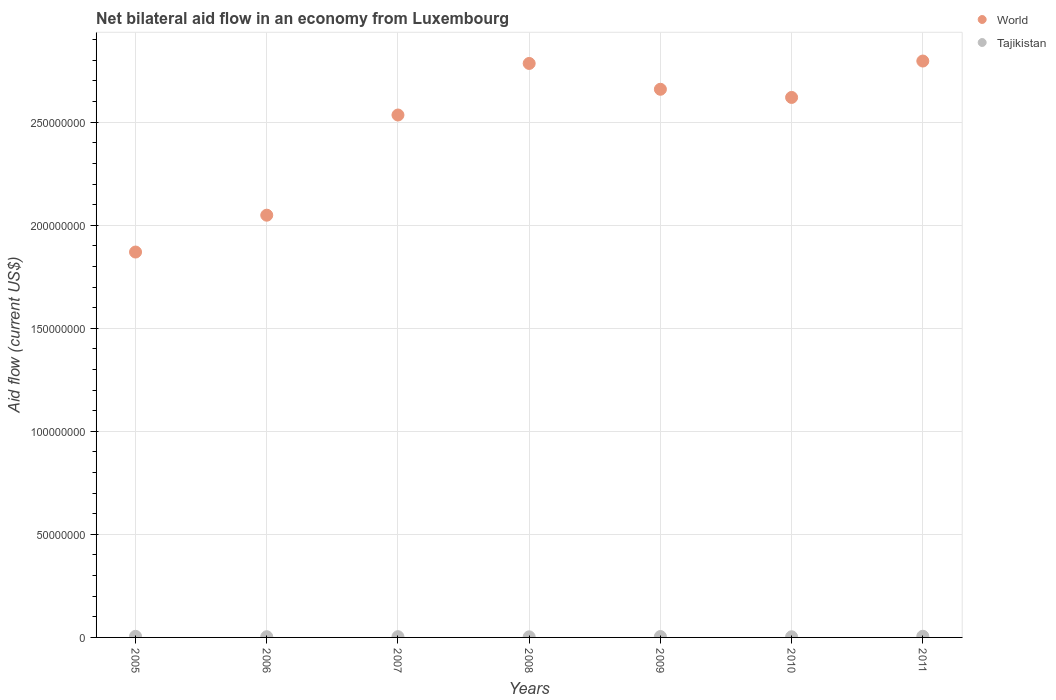How many different coloured dotlines are there?
Your answer should be compact. 2. Across all years, what is the maximum net bilateral aid flow in Tajikistan?
Offer a very short reply. 5.70e+05. Across all years, what is the minimum net bilateral aid flow in World?
Provide a succinct answer. 1.87e+08. In which year was the net bilateral aid flow in Tajikistan minimum?
Give a very brief answer. 2008. What is the total net bilateral aid flow in World in the graph?
Your response must be concise. 1.73e+09. What is the difference between the net bilateral aid flow in Tajikistan in 2006 and the net bilateral aid flow in World in 2011?
Provide a short and direct response. -2.79e+08. What is the average net bilateral aid flow in World per year?
Provide a short and direct response. 2.47e+08. In the year 2005, what is the difference between the net bilateral aid flow in World and net bilateral aid flow in Tajikistan?
Make the answer very short. 1.86e+08. What is the ratio of the net bilateral aid flow in Tajikistan in 2006 to that in 2011?
Offer a very short reply. 0.6. Is the difference between the net bilateral aid flow in World in 2005 and 2010 greater than the difference between the net bilateral aid flow in Tajikistan in 2005 and 2010?
Your response must be concise. No. What is the difference between the highest and the second highest net bilateral aid flow in World?
Offer a very short reply. 1.17e+06. In how many years, is the net bilateral aid flow in Tajikistan greater than the average net bilateral aid flow in Tajikistan taken over all years?
Keep it short and to the point. 3. Is the sum of the net bilateral aid flow in Tajikistan in 2008 and 2010 greater than the maximum net bilateral aid flow in World across all years?
Your response must be concise. No. Does the net bilateral aid flow in World monotonically increase over the years?
Keep it short and to the point. No. Is the net bilateral aid flow in World strictly greater than the net bilateral aid flow in Tajikistan over the years?
Your answer should be very brief. Yes. Is the net bilateral aid flow in Tajikistan strictly less than the net bilateral aid flow in World over the years?
Provide a short and direct response. Yes. How many dotlines are there?
Offer a terse response. 2. How many years are there in the graph?
Offer a terse response. 7. Are the values on the major ticks of Y-axis written in scientific E-notation?
Your response must be concise. No. Does the graph contain any zero values?
Offer a terse response. No. Where does the legend appear in the graph?
Ensure brevity in your answer.  Top right. How many legend labels are there?
Make the answer very short. 2. How are the legend labels stacked?
Offer a very short reply. Vertical. What is the title of the graph?
Your answer should be compact. Net bilateral aid flow in an economy from Luxembourg. What is the label or title of the X-axis?
Offer a terse response. Years. What is the label or title of the Y-axis?
Provide a succinct answer. Aid flow (current US$). What is the Aid flow (current US$) in World in 2005?
Your response must be concise. 1.87e+08. What is the Aid flow (current US$) of Tajikistan in 2005?
Your answer should be very brief. 5.30e+05. What is the Aid flow (current US$) in World in 2006?
Your response must be concise. 2.05e+08. What is the Aid flow (current US$) in Tajikistan in 2006?
Ensure brevity in your answer.  3.40e+05. What is the Aid flow (current US$) of World in 2007?
Keep it short and to the point. 2.53e+08. What is the Aid flow (current US$) in Tajikistan in 2007?
Make the answer very short. 3.60e+05. What is the Aid flow (current US$) of World in 2008?
Keep it short and to the point. 2.79e+08. What is the Aid flow (current US$) of World in 2009?
Provide a short and direct response. 2.66e+08. What is the Aid flow (current US$) of World in 2010?
Make the answer very short. 2.62e+08. What is the Aid flow (current US$) in World in 2011?
Offer a very short reply. 2.80e+08. What is the Aid flow (current US$) in Tajikistan in 2011?
Your response must be concise. 5.70e+05. Across all years, what is the maximum Aid flow (current US$) in World?
Make the answer very short. 2.80e+08. Across all years, what is the maximum Aid flow (current US$) of Tajikistan?
Your answer should be very brief. 5.70e+05. Across all years, what is the minimum Aid flow (current US$) in World?
Offer a very short reply. 1.87e+08. What is the total Aid flow (current US$) of World in the graph?
Your response must be concise. 1.73e+09. What is the total Aid flow (current US$) in Tajikistan in the graph?
Offer a very short reply. 2.84e+06. What is the difference between the Aid flow (current US$) in World in 2005 and that in 2006?
Provide a succinct answer. -1.79e+07. What is the difference between the Aid flow (current US$) in Tajikistan in 2005 and that in 2006?
Give a very brief answer. 1.90e+05. What is the difference between the Aid flow (current US$) of World in 2005 and that in 2007?
Offer a very short reply. -6.65e+07. What is the difference between the Aid flow (current US$) in Tajikistan in 2005 and that in 2007?
Offer a very short reply. 1.70e+05. What is the difference between the Aid flow (current US$) in World in 2005 and that in 2008?
Keep it short and to the point. -9.15e+07. What is the difference between the Aid flow (current US$) of Tajikistan in 2005 and that in 2008?
Your answer should be very brief. 2.40e+05. What is the difference between the Aid flow (current US$) in World in 2005 and that in 2009?
Your answer should be compact. -7.90e+07. What is the difference between the Aid flow (current US$) in World in 2005 and that in 2010?
Your response must be concise. -7.50e+07. What is the difference between the Aid flow (current US$) in World in 2005 and that in 2011?
Offer a terse response. -9.27e+07. What is the difference between the Aid flow (current US$) in Tajikistan in 2005 and that in 2011?
Make the answer very short. -4.00e+04. What is the difference between the Aid flow (current US$) in World in 2006 and that in 2007?
Your response must be concise. -4.86e+07. What is the difference between the Aid flow (current US$) in World in 2006 and that in 2008?
Keep it short and to the point. -7.36e+07. What is the difference between the Aid flow (current US$) of World in 2006 and that in 2009?
Make the answer very short. -6.11e+07. What is the difference between the Aid flow (current US$) of World in 2006 and that in 2010?
Give a very brief answer. -5.71e+07. What is the difference between the Aid flow (current US$) in Tajikistan in 2006 and that in 2010?
Provide a short and direct response. 2.00e+04. What is the difference between the Aid flow (current US$) of World in 2006 and that in 2011?
Give a very brief answer. -7.48e+07. What is the difference between the Aid flow (current US$) of World in 2007 and that in 2008?
Provide a short and direct response. -2.50e+07. What is the difference between the Aid flow (current US$) of World in 2007 and that in 2009?
Keep it short and to the point. -1.25e+07. What is the difference between the Aid flow (current US$) in World in 2007 and that in 2010?
Offer a terse response. -8.53e+06. What is the difference between the Aid flow (current US$) in World in 2007 and that in 2011?
Your response must be concise. -2.62e+07. What is the difference between the Aid flow (current US$) in World in 2008 and that in 2009?
Your answer should be very brief. 1.25e+07. What is the difference between the Aid flow (current US$) of Tajikistan in 2008 and that in 2009?
Your answer should be compact. -1.40e+05. What is the difference between the Aid flow (current US$) in World in 2008 and that in 2010?
Keep it short and to the point. 1.65e+07. What is the difference between the Aid flow (current US$) of Tajikistan in 2008 and that in 2010?
Offer a terse response. -3.00e+04. What is the difference between the Aid flow (current US$) of World in 2008 and that in 2011?
Ensure brevity in your answer.  -1.17e+06. What is the difference between the Aid flow (current US$) in Tajikistan in 2008 and that in 2011?
Offer a very short reply. -2.80e+05. What is the difference between the Aid flow (current US$) in World in 2009 and that in 2010?
Give a very brief answer. 3.96e+06. What is the difference between the Aid flow (current US$) of Tajikistan in 2009 and that in 2010?
Your answer should be compact. 1.10e+05. What is the difference between the Aid flow (current US$) of World in 2009 and that in 2011?
Keep it short and to the point. -1.37e+07. What is the difference between the Aid flow (current US$) in World in 2010 and that in 2011?
Your answer should be very brief. -1.77e+07. What is the difference between the Aid flow (current US$) in World in 2005 and the Aid flow (current US$) in Tajikistan in 2006?
Offer a terse response. 1.87e+08. What is the difference between the Aid flow (current US$) in World in 2005 and the Aid flow (current US$) in Tajikistan in 2007?
Your response must be concise. 1.87e+08. What is the difference between the Aid flow (current US$) of World in 2005 and the Aid flow (current US$) of Tajikistan in 2008?
Provide a succinct answer. 1.87e+08. What is the difference between the Aid flow (current US$) of World in 2005 and the Aid flow (current US$) of Tajikistan in 2009?
Keep it short and to the point. 1.87e+08. What is the difference between the Aid flow (current US$) in World in 2005 and the Aid flow (current US$) in Tajikistan in 2010?
Ensure brevity in your answer.  1.87e+08. What is the difference between the Aid flow (current US$) in World in 2005 and the Aid flow (current US$) in Tajikistan in 2011?
Make the answer very short. 1.86e+08. What is the difference between the Aid flow (current US$) of World in 2006 and the Aid flow (current US$) of Tajikistan in 2007?
Provide a succinct answer. 2.05e+08. What is the difference between the Aid flow (current US$) in World in 2006 and the Aid flow (current US$) in Tajikistan in 2008?
Provide a succinct answer. 2.05e+08. What is the difference between the Aid flow (current US$) in World in 2006 and the Aid flow (current US$) in Tajikistan in 2009?
Ensure brevity in your answer.  2.04e+08. What is the difference between the Aid flow (current US$) in World in 2006 and the Aid flow (current US$) in Tajikistan in 2010?
Your answer should be very brief. 2.05e+08. What is the difference between the Aid flow (current US$) in World in 2006 and the Aid flow (current US$) in Tajikistan in 2011?
Provide a succinct answer. 2.04e+08. What is the difference between the Aid flow (current US$) in World in 2007 and the Aid flow (current US$) in Tajikistan in 2008?
Your answer should be compact. 2.53e+08. What is the difference between the Aid flow (current US$) in World in 2007 and the Aid flow (current US$) in Tajikistan in 2009?
Your answer should be very brief. 2.53e+08. What is the difference between the Aid flow (current US$) in World in 2007 and the Aid flow (current US$) in Tajikistan in 2010?
Keep it short and to the point. 2.53e+08. What is the difference between the Aid flow (current US$) of World in 2007 and the Aid flow (current US$) of Tajikistan in 2011?
Your answer should be very brief. 2.53e+08. What is the difference between the Aid flow (current US$) of World in 2008 and the Aid flow (current US$) of Tajikistan in 2009?
Offer a very short reply. 2.78e+08. What is the difference between the Aid flow (current US$) of World in 2008 and the Aid flow (current US$) of Tajikistan in 2010?
Give a very brief answer. 2.78e+08. What is the difference between the Aid flow (current US$) in World in 2008 and the Aid flow (current US$) in Tajikistan in 2011?
Make the answer very short. 2.78e+08. What is the difference between the Aid flow (current US$) of World in 2009 and the Aid flow (current US$) of Tajikistan in 2010?
Ensure brevity in your answer.  2.66e+08. What is the difference between the Aid flow (current US$) of World in 2009 and the Aid flow (current US$) of Tajikistan in 2011?
Offer a very short reply. 2.65e+08. What is the difference between the Aid flow (current US$) of World in 2010 and the Aid flow (current US$) of Tajikistan in 2011?
Provide a short and direct response. 2.61e+08. What is the average Aid flow (current US$) in World per year?
Provide a short and direct response. 2.47e+08. What is the average Aid flow (current US$) in Tajikistan per year?
Provide a succinct answer. 4.06e+05. In the year 2005, what is the difference between the Aid flow (current US$) of World and Aid flow (current US$) of Tajikistan?
Give a very brief answer. 1.86e+08. In the year 2006, what is the difference between the Aid flow (current US$) of World and Aid flow (current US$) of Tajikistan?
Give a very brief answer. 2.05e+08. In the year 2007, what is the difference between the Aid flow (current US$) of World and Aid flow (current US$) of Tajikistan?
Provide a succinct answer. 2.53e+08. In the year 2008, what is the difference between the Aid flow (current US$) of World and Aid flow (current US$) of Tajikistan?
Make the answer very short. 2.78e+08. In the year 2009, what is the difference between the Aid flow (current US$) of World and Aid flow (current US$) of Tajikistan?
Keep it short and to the point. 2.66e+08. In the year 2010, what is the difference between the Aid flow (current US$) of World and Aid flow (current US$) of Tajikistan?
Your answer should be very brief. 2.62e+08. In the year 2011, what is the difference between the Aid flow (current US$) of World and Aid flow (current US$) of Tajikistan?
Provide a succinct answer. 2.79e+08. What is the ratio of the Aid flow (current US$) in World in 2005 to that in 2006?
Make the answer very short. 0.91. What is the ratio of the Aid flow (current US$) in Tajikistan in 2005 to that in 2006?
Give a very brief answer. 1.56. What is the ratio of the Aid flow (current US$) in World in 2005 to that in 2007?
Give a very brief answer. 0.74. What is the ratio of the Aid flow (current US$) in Tajikistan in 2005 to that in 2007?
Offer a very short reply. 1.47. What is the ratio of the Aid flow (current US$) in World in 2005 to that in 2008?
Keep it short and to the point. 0.67. What is the ratio of the Aid flow (current US$) of Tajikistan in 2005 to that in 2008?
Your response must be concise. 1.83. What is the ratio of the Aid flow (current US$) in World in 2005 to that in 2009?
Offer a terse response. 0.7. What is the ratio of the Aid flow (current US$) in Tajikistan in 2005 to that in 2009?
Your answer should be very brief. 1.23. What is the ratio of the Aid flow (current US$) of World in 2005 to that in 2010?
Offer a terse response. 0.71. What is the ratio of the Aid flow (current US$) in Tajikistan in 2005 to that in 2010?
Keep it short and to the point. 1.66. What is the ratio of the Aid flow (current US$) of World in 2005 to that in 2011?
Provide a succinct answer. 0.67. What is the ratio of the Aid flow (current US$) in Tajikistan in 2005 to that in 2011?
Ensure brevity in your answer.  0.93. What is the ratio of the Aid flow (current US$) of World in 2006 to that in 2007?
Ensure brevity in your answer.  0.81. What is the ratio of the Aid flow (current US$) of World in 2006 to that in 2008?
Your answer should be compact. 0.74. What is the ratio of the Aid flow (current US$) in Tajikistan in 2006 to that in 2008?
Ensure brevity in your answer.  1.17. What is the ratio of the Aid flow (current US$) of World in 2006 to that in 2009?
Your answer should be very brief. 0.77. What is the ratio of the Aid flow (current US$) of Tajikistan in 2006 to that in 2009?
Make the answer very short. 0.79. What is the ratio of the Aid flow (current US$) in World in 2006 to that in 2010?
Offer a terse response. 0.78. What is the ratio of the Aid flow (current US$) in Tajikistan in 2006 to that in 2010?
Your answer should be compact. 1.06. What is the ratio of the Aid flow (current US$) in World in 2006 to that in 2011?
Offer a very short reply. 0.73. What is the ratio of the Aid flow (current US$) in Tajikistan in 2006 to that in 2011?
Your response must be concise. 0.6. What is the ratio of the Aid flow (current US$) of World in 2007 to that in 2008?
Provide a succinct answer. 0.91. What is the ratio of the Aid flow (current US$) in Tajikistan in 2007 to that in 2008?
Provide a succinct answer. 1.24. What is the ratio of the Aid flow (current US$) in World in 2007 to that in 2009?
Give a very brief answer. 0.95. What is the ratio of the Aid flow (current US$) in Tajikistan in 2007 to that in 2009?
Provide a short and direct response. 0.84. What is the ratio of the Aid flow (current US$) of World in 2007 to that in 2010?
Keep it short and to the point. 0.97. What is the ratio of the Aid flow (current US$) of World in 2007 to that in 2011?
Your answer should be very brief. 0.91. What is the ratio of the Aid flow (current US$) of Tajikistan in 2007 to that in 2011?
Provide a short and direct response. 0.63. What is the ratio of the Aid flow (current US$) in World in 2008 to that in 2009?
Offer a very short reply. 1.05. What is the ratio of the Aid flow (current US$) in Tajikistan in 2008 to that in 2009?
Your response must be concise. 0.67. What is the ratio of the Aid flow (current US$) of World in 2008 to that in 2010?
Your answer should be compact. 1.06. What is the ratio of the Aid flow (current US$) of Tajikistan in 2008 to that in 2010?
Offer a very short reply. 0.91. What is the ratio of the Aid flow (current US$) in World in 2008 to that in 2011?
Ensure brevity in your answer.  1. What is the ratio of the Aid flow (current US$) in Tajikistan in 2008 to that in 2011?
Offer a terse response. 0.51. What is the ratio of the Aid flow (current US$) in World in 2009 to that in 2010?
Your response must be concise. 1.02. What is the ratio of the Aid flow (current US$) of Tajikistan in 2009 to that in 2010?
Your answer should be very brief. 1.34. What is the ratio of the Aid flow (current US$) in World in 2009 to that in 2011?
Your answer should be compact. 0.95. What is the ratio of the Aid flow (current US$) of Tajikistan in 2009 to that in 2011?
Provide a short and direct response. 0.75. What is the ratio of the Aid flow (current US$) in World in 2010 to that in 2011?
Ensure brevity in your answer.  0.94. What is the ratio of the Aid flow (current US$) of Tajikistan in 2010 to that in 2011?
Your answer should be very brief. 0.56. What is the difference between the highest and the second highest Aid flow (current US$) in World?
Offer a terse response. 1.17e+06. What is the difference between the highest and the second highest Aid flow (current US$) of Tajikistan?
Provide a succinct answer. 4.00e+04. What is the difference between the highest and the lowest Aid flow (current US$) of World?
Offer a terse response. 9.27e+07. What is the difference between the highest and the lowest Aid flow (current US$) in Tajikistan?
Ensure brevity in your answer.  2.80e+05. 